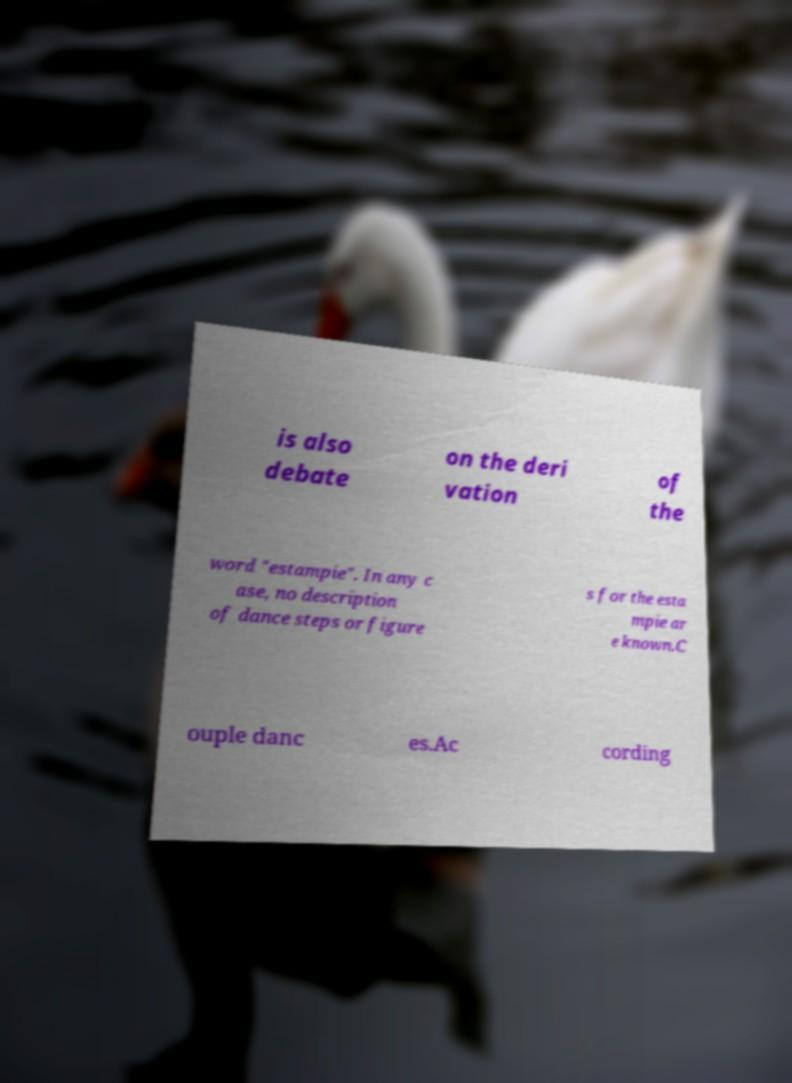Please identify and transcribe the text found in this image. is also debate on the deri vation of the word "estampie". In any c ase, no description of dance steps or figure s for the esta mpie ar e known.C ouple danc es.Ac cording 